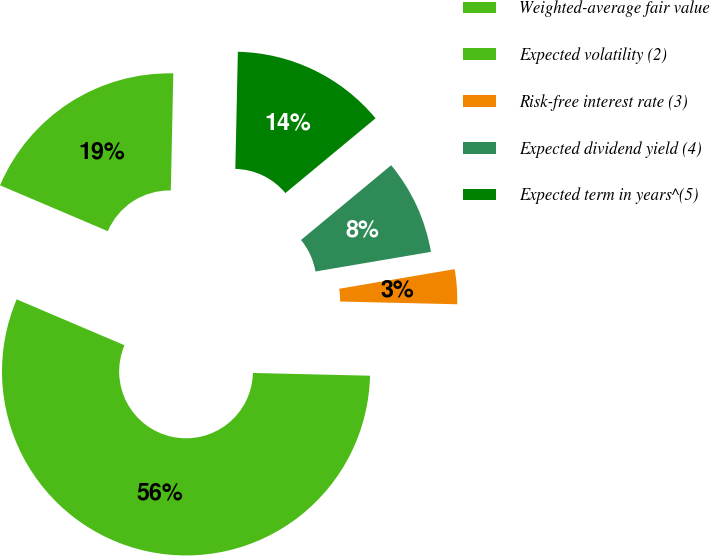Convert chart to OTSL. <chart><loc_0><loc_0><loc_500><loc_500><pie_chart><fcel>Weighted-average fair value<fcel>Expected volatility (2)<fcel>Risk-free interest rate (3)<fcel>Expected dividend yield (4)<fcel>Expected term in years^(5)<nl><fcel>18.94%<fcel>56.03%<fcel>3.05%<fcel>8.34%<fcel>13.64%<nl></chart> 